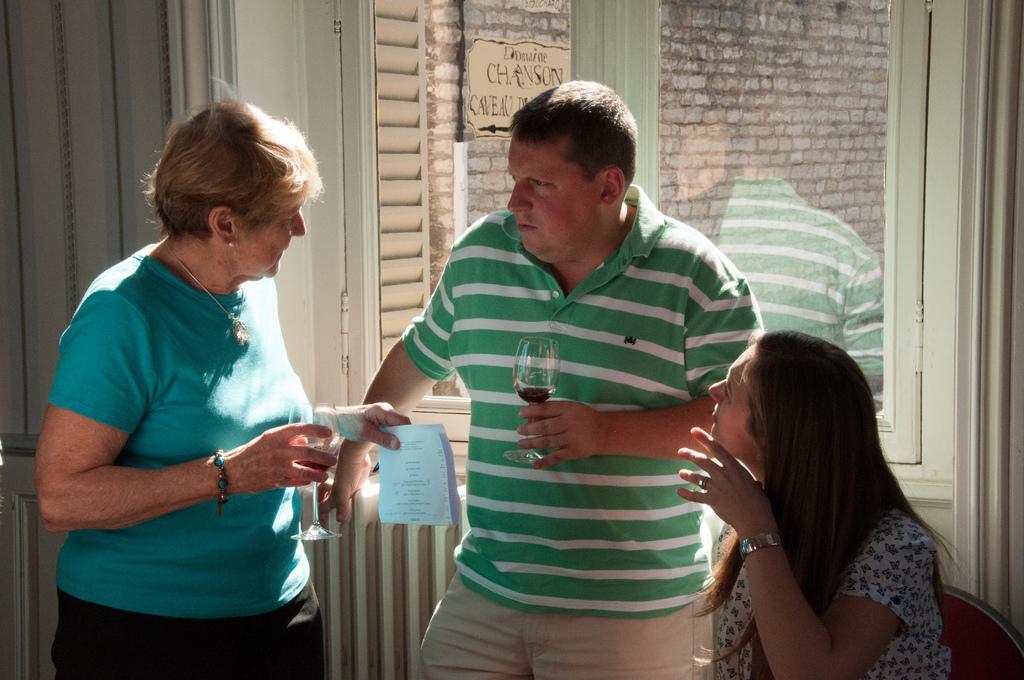Could you give a brief overview of what you see in this image? In this picture we can see a person holding a glass. We can see a woman holding objects in her hands. We can see a person sitting on a chair. There are glass objects. Through these glass objects, we can see the text on the board and a wall in the background. 